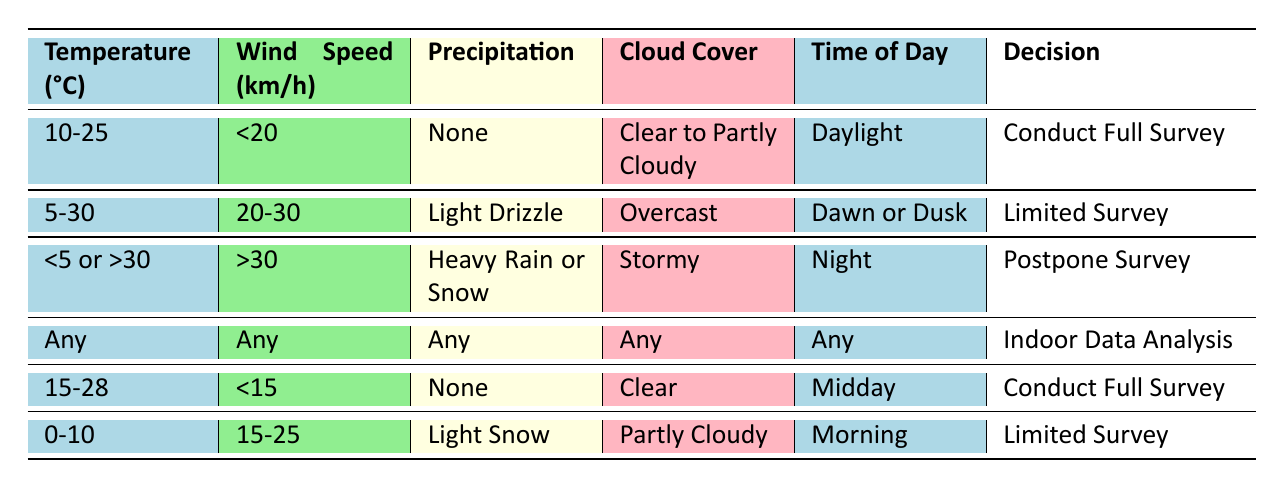What is the decision if the temperature is 20°C and wind speed is 15 km/h? The temperature is within the range of 10-25°C and the wind speed is less than 20 km/h, which fits the criteria for "Conduct Full Survey" in the first row.
Answer: Conduct Full Survey Is a limited survey conducted if the temperature is 6°C with light drizzle? The temperature of 6°C does not fall within the range of 5-30°C for light drizzle, so it does not fulfill any condition for a limited survey based on the second rule.
Answer: No What is the temperature range that leads to postponing a survey? The table indicates postponing the survey occurs when the temperature is less than 5 or greater than 30 degrees. These conditions are outlined in the third row.
Answer: <5 or >30 If it is between 15-28°C, what is the wind speed limit for a full survey? Based on the fifth row, the wind speed must be less than 15 km/h for conducting a full survey in this temperature range.
Answer: <15 km/h Is it daylight if a limited survey is being conducted? The second row specifies that a limited survey can only occur during dawn or dusk; therefore, it cannot be in full daylight.
Answer: No What time of day can a full survey be conducted at a temperature of 15°C? According to the first row, a full survey can be conducted during daylight given that the temperature falls between 10-25°C, which includes 15°C.
Answer: Daylight Calculate the average wind speed range specified for limited surveys. The limited surveys occur at wind speeds of 20-30 km/h (from the second row) and also at 15-25 km/h (from the sixth row). Calculating the average of these ranges: (20 + 30) / 2 = 25 and (15 + 25) / 2 = 20, so the average of the two averages is (25 + 20) / 2 = 22.5 km/h, which captures the midrange of both.
Answer: 22.5 km/h Is there any condition with no precipitation required for conducting a full survey? Yes, reference the rows that stipulate "None" under precipitation for the full surveys in the first and fifth rules.
Answer: Yes What are the two primary conditions needed for a limited survey? From the second and sixth rows, the primary conditions are: 1) Light Drizzle with temperature 5-30°C and wind speed 20-30 km/h; 2) Light Snow with temperature 0-10°C and wind speed 15-25 km/h.
Answer: Light Drizzle and Light Snow 